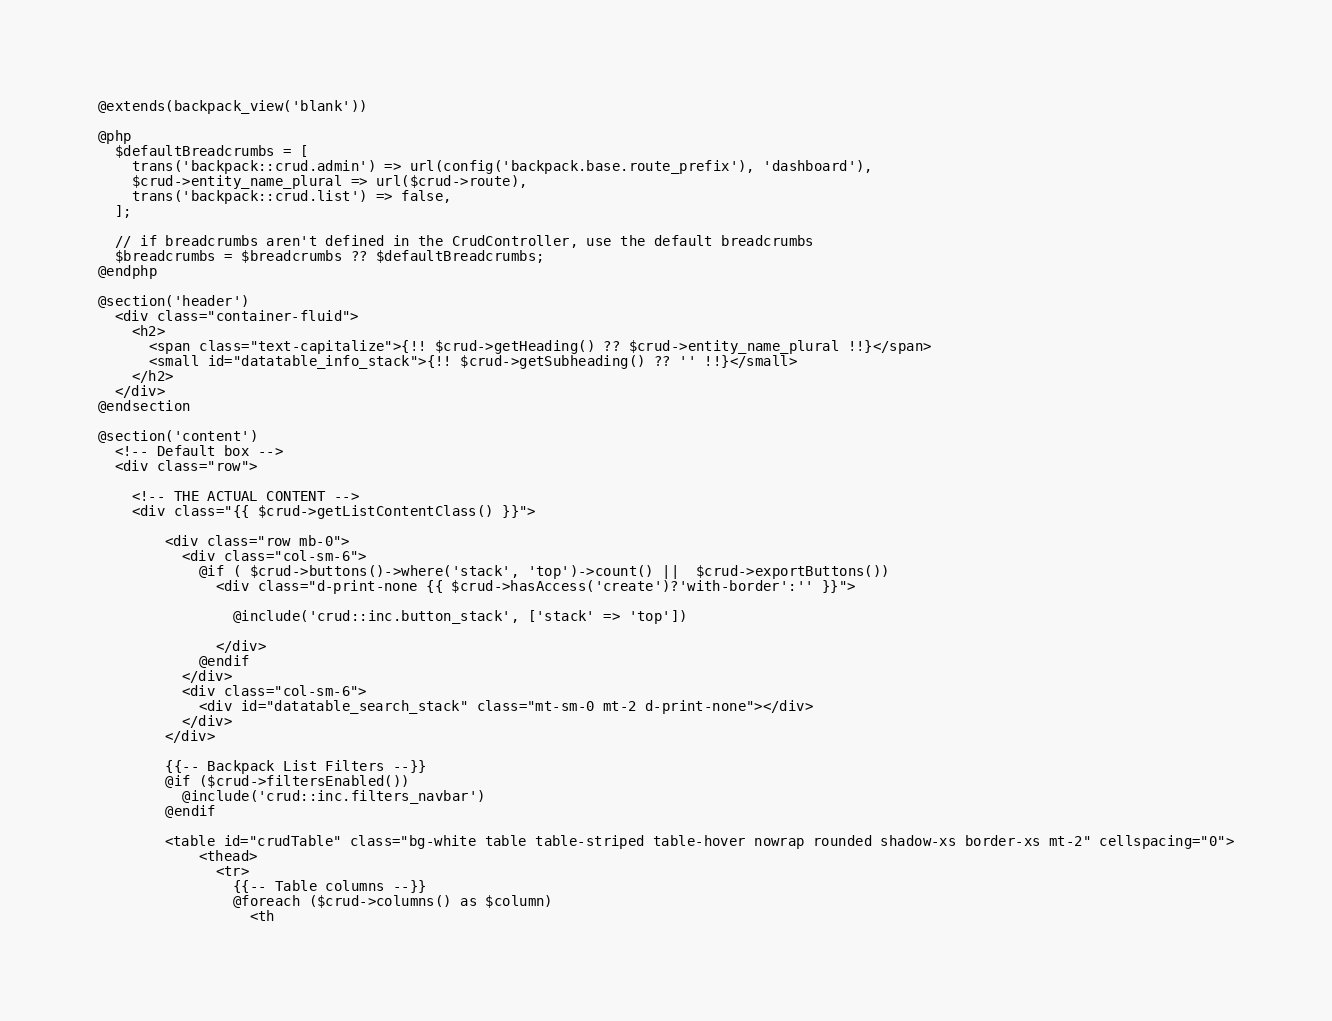<code> <loc_0><loc_0><loc_500><loc_500><_PHP_>@extends(backpack_view('blank'))

@php
  $defaultBreadcrumbs = [
    trans('backpack::crud.admin') => url(config('backpack.base.route_prefix'), 'dashboard'),
    $crud->entity_name_plural => url($crud->route),
    trans('backpack::crud.list') => false,
  ];

  // if breadcrumbs aren't defined in the CrudController, use the default breadcrumbs
  $breadcrumbs = $breadcrumbs ?? $defaultBreadcrumbs;
@endphp

@section('header')
  <div class="container-fluid">
    <h2>
      <span class="text-capitalize">{!! $crud->getHeading() ?? $crud->entity_name_plural !!}</span>
      <small id="datatable_info_stack">{!! $crud->getSubheading() ?? '' !!}</small>
    </h2>
  </div>
@endsection

@section('content')
  <!-- Default box -->
  <div class="row">

    <!-- THE ACTUAL CONTENT -->
    <div class="{{ $crud->getListContentClass() }}">

        <div class="row mb-0">
          <div class="col-sm-6">
            @if ( $crud->buttons()->where('stack', 'top')->count() ||  $crud->exportButtons())
              <div class="d-print-none {{ $crud->hasAccess('create')?'with-border':'' }}">

                @include('crud::inc.button_stack', ['stack' => 'top'])

              </div>
            @endif
          </div>
          <div class="col-sm-6">
            <div id="datatable_search_stack" class="mt-sm-0 mt-2 d-print-none"></div>
          </div>
        </div>

        {{-- Backpack List Filters --}}
        @if ($crud->filtersEnabled())
          @include('crud::inc.filters_navbar')
        @endif

        <table id="crudTable" class="bg-white table table-striped table-hover nowrap rounded shadow-xs border-xs mt-2" cellspacing="0">
            <thead>
              <tr>
                {{-- Table columns --}}
                @foreach ($crud->columns() as $column)
                  <th</code> 